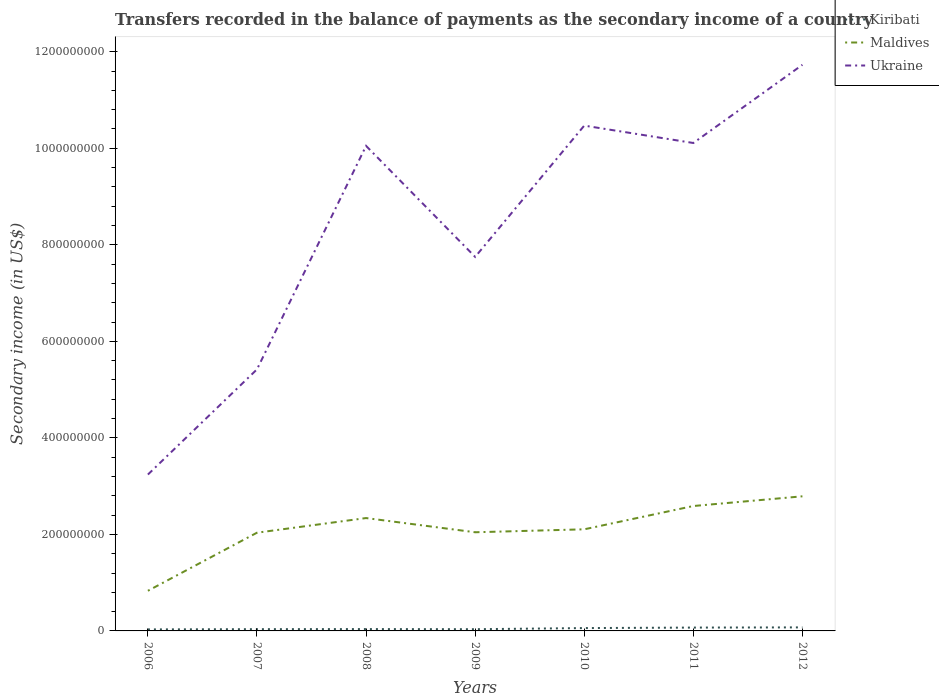Does the line corresponding to Ukraine intersect with the line corresponding to Kiribati?
Make the answer very short. No. Across all years, what is the maximum secondary income of in Kiribati?
Keep it short and to the point. 3.14e+06. In which year was the secondary income of in Ukraine maximum?
Offer a terse response. 2006. What is the total secondary income of in Kiribati in the graph?
Your answer should be compact. -3.76e+06. What is the difference between the highest and the second highest secondary income of in Ukraine?
Provide a short and direct response. 8.49e+08. Is the secondary income of in Kiribati strictly greater than the secondary income of in Maldives over the years?
Give a very brief answer. Yes. How many lines are there?
Your answer should be compact. 3. How many years are there in the graph?
Offer a terse response. 7. What is the difference between two consecutive major ticks on the Y-axis?
Offer a very short reply. 2.00e+08. Are the values on the major ticks of Y-axis written in scientific E-notation?
Give a very brief answer. No. Does the graph contain grids?
Offer a very short reply. No. Where does the legend appear in the graph?
Provide a succinct answer. Top right. How are the legend labels stacked?
Ensure brevity in your answer.  Vertical. What is the title of the graph?
Give a very brief answer. Transfers recorded in the balance of payments as the secondary income of a country. What is the label or title of the Y-axis?
Provide a short and direct response. Secondary income (in US$). What is the Secondary income (in US$) of Kiribati in 2006?
Your response must be concise. 3.14e+06. What is the Secondary income (in US$) in Maldives in 2006?
Offer a very short reply. 8.32e+07. What is the Secondary income (in US$) in Ukraine in 2006?
Offer a terse response. 3.24e+08. What is the Secondary income (in US$) in Kiribati in 2007?
Make the answer very short. 3.62e+06. What is the Secondary income (in US$) of Maldives in 2007?
Offer a terse response. 2.04e+08. What is the Secondary income (in US$) of Ukraine in 2007?
Keep it short and to the point. 5.42e+08. What is the Secondary income (in US$) in Kiribati in 2008?
Ensure brevity in your answer.  3.81e+06. What is the Secondary income (in US$) in Maldives in 2008?
Ensure brevity in your answer.  2.34e+08. What is the Secondary income (in US$) of Ukraine in 2008?
Ensure brevity in your answer.  1.00e+09. What is the Secondary income (in US$) in Kiribati in 2009?
Make the answer very short. 3.55e+06. What is the Secondary income (in US$) in Maldives in 2009?
Provide a short and direct response. 2.04e+08. What is the Secondary income (in US$) of Ukraine in 2009?
Your answer should be very brief. 7.75e+08. What is the Secondary income (in US$) of Kiribati in 2010?
Provide a short and direct response. 5.89e+06. What is the Secondary income (in US$) in Maldives in 2010?
Your response must be concise. 2.11e+08. What is the Secondary income (in US$) in Ukraine in 2010?
Your answer should be compact. 1.05e+09. What is the Secondary income (in US$) of Kiribati in 2011?
Provide a succinct answer. 6.92e+06. What is the Secondary income (in US$) of Maldives in 2011?
Provide a succinct answer. 2.59e+08. What is the Secondary income (in US$) of Ukraine in 2011?
Make the answer very short. 1.01e+09. What is the Secondary income (in US$) of Kiribati in 2012?
Provide a succinct answer. 7.31e+06. What is the Secondary income (in US$) of Maldives in 2012?
Ensure brevity in your answer.  2.79e+08. What is the Secondary income (in US$) in Ukraine in 2012?
Provide a short and direct response. 1.17e+09. Across all years, what is the maximum Secondary income (in US$) of Kiribati?
Provide a short and direct response. 7.31e+06. Across all years, what is the maximum Secondary income (in US$) in Maldives?
Offer a very short reply. 2.79e+08. Across all years, what is the maximum Secondary income (in US$) in Ukraine?
Your response must be concise. 1.17e+09. Across all years, what is the minimum Secondary income (in US$) of Kiribati?
Provide a short and direct response. 3.14e+06. Across all years, what is the minimum Secondary income (in US$) in Maldives?
Your response must be concise. 8.32e+07. Across all years, what is the minimum Secondary income (in US$) of Ukraine?
Your answer should be compact. 3.24e+08. What is the total Secondary income (in US$) in Kiribati in the graph?
Offer a very short reply. 3.42e+07. What is the total Secondary income (in US$) of Maldives in the graph?
Provide a succinct answer. 1.47e+09. What is the total Secondary income (in US$) of Ukraine in the graph?
Provide a succinct answer. 5.88e+09. What is the difference between the Secondary income (in US$) of Kiribati in 2006 and that in 2007?
Keep it short and to the point. -4.79e+05. What is the difference between the Secondary income (in US$) in Maldives in 2006 and that in 2007?
Offer a terse response. -1.20e+08. What is the difference between the Secondary income (in US$) in Ukraine in 2006 and that in 2007?
Give a very brief answer. -2.18e+08. What is the difference between the Secondary income (in US$) of Kiribati in 2006 and that in 2008?
Provide a succinct answer. -6.70e+05. What is the difference between the Secondary income (in US$) of Maldives in 2006 and that in 2008?
Ensure brevity in your answer.  -1.51e+08. What is the difference between the Secondary income (in US$) in Ukraine in 2006 and that in 2008?
Make the answer very short. -6.81e+08. What is the difference between the Secondary income (in US$) of Kiribati in 2006 and that in 2009?
Offer a very short reply. -4.10e+05. What is the difference between the Secondary income (in US$) in Maldives in 2006 and that in 2009?
Your answer should be very brief. -1.21e+08. What is the difference between the Secondary income (in US$) of Ukraine in 2006 and that in 2009?
Offer a terse response. -4.51e+08. What is the difference between the Secondary income (in US$) in Kiribati in 2006 and that in 2010?
Your response must be concise. -2.75e+06. What is the difference between the Secondary income (in US$) in Maldives in 2006 and that in 2010?
Make the answer very short. -1.27e+08. What is the difference between the Secondary income (in US$) in Ukraine in 2006 and that in 2010?
Provide a short and direct response. -7.23e+08. What is the difference between the Secondary income (in US$) in Kiribati in 2006 and that in 2011?
Provide a succinct answer. -3.78e+06. What is the difference between the Secondary income (in US$) in Maldives in 2006 and that in 2011?
Provide a succinct answer. -1.76e+08. What is the difference between the Secondary income (in US$) of Ukraine in 2006 and that in 2011?
Your response must be concise. -6.87e+08. What is the difference between the Secondary income (in US$) of Kiribati in 2006 and that in 2012?
Your answer should be compact. -4.17e+06. What is the difference between the Secondary income (in US$) of Maldives in 2006 and that in 2012?
Offer a terse response. -1.96e+08. What is the difference between the Secondary income (in US$) of Ukraine in 2006 and that in 2012?
Offer a terse response. -8.49e+08. What is the difference between the Secondary income (in US$) in Kiribati in 2007 and that in 2008?
Provide a short and direct response. -1.90e+05. What is the difference between the Secondary income (in US$) in Maldives in 2007 and that in 2008?
Provide a short and direct response. -3.03e+07. What is the difference between the Secondary income (in US$) of Ukraine in 2007 and that in 2008?
Keep it short and to the point. -4.63e+08. What is the difference between the Secondary income (in US$) of Kiribati in 2007 and that in 2009?
Provide a short and direct response. 6.99e+04. What is the difference between the Secondary income (in US$) of Maldives in 2007 and that in 2009?
Provide a short and direct response. -8.88e+05. What is the difference between the Secondary income (in US$) of Ukraine in 2007 and that in 2009?
Your answer should be very brief. -2.33e+08. What is the difference between the Secondary income (in US$) in Kiribati in 2007 and that in 2010?
Provide a succinct answer. -2.28e+06. What is the difference between the Secondary income (in US$) in Maldives in 2007 and that in 2010?
Your answer should be very brief. -7.01e+06. What is the difference between the Secondary income (in US$) in Ukraine in 2007 and that in 2010?
Provide a succinct answer. -5.05e+08. What is the difference between the Secondary income (in US$) in Kiribati in 2007 and that in 2011?
Give a very brief answer. -3.30e+06. What is the difference between the Secondary income (in US$) of Maldives in 2007 and that in 2011?
Provide a succinct answer. -5.53e+07. What is the difference between the Secondary income (in US$) in Ukraine in 2007 and that in 2011?
Provide a succinct answer. -4.69e+08. What is the difference between the Secondary income (in US$) in Kiribati in 2007 and that in 2012?
Your answer should be very brief. -3.69e+06. What is the difference between the Secondary income (in US$) in Maldives in 2007 and that in 2012?
Provide a succinct answer. -7.54e+07. What is the difference between the Secondary income (in US$) in Ukraine in 2007 and that in 2012?
Provide a succinct answer. -6.31e+08. What is the difference between the Secondary income (in US$) of Kiribati in 2008 and that in 2009?
Your response must be concise. 2.60e+05. What is the difference between the Secondary income (in US$) in Maldives in 2008 and that in 2009?
Provide a succinct answer. 2.94e+07. What is the difference between the Secondary income (in US$) in Ukraine in 2008 and that in 2009?
Provide a succinct answer. 2.30e+08. What is the difference between the Secondary income (in US$) of Kiribati in 2008 and that in 2010?
Give a very brief answer. -2.09e+06. What is the difference between the Secondary income (in US$) in Maldives in 2008 and that in 2010?
Make the answer very short. 2.33e+07. What is the difference between the Secondary income (in US$) in Ukraine in 2008 and that in 2010?
Ensure brevity in your answer.  -4.20e+07. What is the difference between the Secondary income (in US$) in Kiribati in 2008 and that in 2011?
Make the answer very short. -3.11e+06. What is the difference between the Secondary income (in US$) of Maldives in 2008 and that in 2011?
Provide a short and direct response. -2.50e+07. What is the difference between the Secondary income (in US$) of Ukraine in 2008 and that in 2011?
Ensure brevity in your answer.  -6.00e+06. What is the difference between the Secondary income (in US$) of Kiribati in 2008 and that in 2012?
Make the answer very short. -3.50e+06. What is the difference between the Secondary income (in US$) in Maldives in 2008 and that in 2012?
Your answer should be very brief. -4.51e+07. What is the difference between the Secondary income (in US$) in Ukraine in 2008 and that in 2012?
Provide a short and direct response. -1.68e+08. What is the difference between the Secondary income (in US$) in Kiribati in 2009 and that in 2010?
Give a very brief answer. -2.35e+06. What is the difference between the Secondary income (in US$) of Maldives in 2009 and that in 2010?
Make the answer very short. -6.12e+06. What is the difference between the Secondary income (in US$) in Ukraine in 2009 and that in 2010?
Your answer should be very brief. -2.72e+08. What is the difference between the Secondary income (in US$) of Kiribati in 2009 and that in 2011?
Your response must be concise. -3.37e+06. What is the difference between the Secondary income (in US$) of Maldives in 2009 and that in 2011?
Give a very brief answer. -5.44e+07. What is the difference between the Secondary income (in US$) of Ukraine in 2009 and that in 2011?
Keep it short and to the point. -2.36e+08. What is the difference between the Secondary income (in US$) of Kiribati in 2009 and that in 2012?
Ensure brevity in your answer.  -3.76e+06. What is the difference between the Secondary income (in US$) of Maldives in 2009 and that in 2012?
Give a very brief answer. -7.45e+07. What is the difference between the Secondary income (in US$) of Ukraine in 2009 and that in 2012?
Offer a terse response. -3.98e+08. What is the difference between the Secondary income (in US$) in Kiribati in 2010 and that in 2011?
Provide a short and direct response. -1.03e+06. What is the difference between the Secondary income (in US$) of Maldives in 2010 and that in 2011?
Provide a short and direct response. -4.83e+07. What is the difference between the Secondary income (in US$) in Ukraine in 2010 and that in 2011?
Make the answer very short. 3.60e+07. What is the difference between the Secondary income (in US$) of Kiribati in 2010 and that in 2012?
Offer a terse response. -1.42e+06. What is the difference between the Secondary income (in US$) in Maldives in 2010 and that in 2012?
Ensure brevity in your answer.  -6.84e+07. What is the difference between the Secondary income (in US$) of Ukraine in 2010 and that in 2012?
Provide a succinct answer. -1.26e+08. What is the difference between the Secondary income (in US$) of Kiribati in 2011 and that in 2012?
Keep it short and to the point. -3.91e+05. What is the difference between the Secondary income (in US$) of Maldives in 2011 and that in 2012?
Provide a succinct answer. -2.01e+07. What is the difference between the Secondary income (in US$) in Ukraine in 2011 and that in 2012?
Ensure brevity in your answer.  -1.62e+08. What is the difference between the Secondary income (in US$) in Kiribati in 2006 and the Secondary income (in US$) in Maldives in 2007?
Offer a terse response. -2.00e+08. What is the difference between the Secondary income (in US$) of Kiribati in 2006 and the Secondary income (in US$) of Ukraine in 2007?
Offer a terse response. -5.39e+08. What is the difference between the Secondary income (in US$) of Maldives in 2006 and the Secondary income (in US$) of Ukraine in 2007?
Ensure brevity in your answer.  -4.59e+08. What is the difference between the Secondary income (in US$) of Kiribati in 2006 and the Secondary income (in US$) of Maldives in 2008?
Provide a succinct answer. -2.31e+08. What is the difference between the Secondary income (in US$) of Kiribati in 2006 and the Secondary income (in US$) of Ukraine in 2008?
Give a very brief answer. -1.00e+09. What is the difference between the Secondary income (in US$) of Maldives in 2006 and the Secondary income (in US$) of Ukraine in 2008?
Your answer should be very brief. -9.22e+08. What is the difference between the Secondary income (in US$) of Kiribati in 2006 and the Secondary income (in US$) of Maldives in 2009?
Make the answer very short. -2.01e+08. What is the difference between the Secondary income (in US$) in Kiribati in 2006 and the Secondary income (in US$) in Ukraine in 2009?
Offer a very short reply. -7.72e+08. What is the difference between the Secondary income (in US$) of Maldives in 2006 and the Secondary income (in US$) of Ukraine in 2009?
Make the answer very short. -6.92e+08. What is the difference between the Secondary income (in US$) in Kiribati in 2006 and the Secondary income (in US$) in Maldives in 2010?
Provide a short and direct response. -2.07e+08. What is the difference between the Secondary income (in US$) in Kiribati in 2006 and the Secondary income (in US$) in Ukraine in 2010?
Make the answer very short. -1.04e+09. What is the difference between the Secondary income (in US$) in Maldives in 2006 and the Secondary income (in US$) in Ukraine in 2010?
Your answer should be very brief. -9.64e+08. What is the difference between the Secondary income (in US$) of Kiribati in 2006 and the Secondary income (in US$) of Maldives in 2011?
Provide a succinct answer. -2.56e+08. What is the difference between the Secondary income (in US$) in Kiribati in 2006 and the Secondary income (in US$) in Ukraine in 2011?
Offer a very short reply. -1.01e+09. What is the difference between the Secondary income (in US$) in Maldives in 2006 and the Secondary income (in US$) in Ukraine in 2011?
Make the answer very short. -9.28e+08. What is the difference between the Secondary income (in US$) of Kiribati in 2006 and the Secondary income (in US$) of Maldives in 2012?
Offer a very short reply. -2.76e+08. What is the difference between the Secondary income (in US$) of Kiribati in 2006 and the Secondary income (in US$) of Ukraine in 2012?
Provide a short and direct response. -1.17e+09. What is the difference between the Secondary income (in US$) in Maldives in 2006 and the Secondary income (in US$) in Ukraine in 2012?
Your answer should be very brief. -1.09e+09. What is the difference between the Secondary income (in US$) in Kiribati in 2007 and the Secondary income (in US$) in Maldives in 2008?
Your answer should be very brief. -2.30e+08. What is the difference between the Secondary income (in US$) in Kiribati in 2007 and the Secondary income (in US$) in Ukraine in 2008?
Provide a succinct answer. -1.00e+09. What is the difference between the Secondary income (in US$) in Maldives in 2007 and the Secondary income (in US$) in Ukraine in 2008?
Your answer should be compact. -8.01e+08. What is the difference between the Secondary income (in US$) in Kiribati in 2007 and the Secondary income (in US$) in Maldives in 2009?
Ensure brevity in your answer.  -2.01e+08. What is the difference between the Secondary income (in US$) of Kiribati in 2007 and the Secondary income (in US$) of Ukraine in 2009?
Offer a terse response. -7.71e+08. What is the difference between the Secondary income (in US$) of Maldives in 2007 and the Secondary income (in US$) of Ukraine in 2009?
Offer a terse response. -5.71e+08. What is the difference between the Secondary income (in US$) in Kiribati in 2007 and the Secondary income (in US$) in Maldives in 2010?
Give a very brief answer. -2.07e+08. What is the difference between the Secondary income (in US$) of Kiribati in 2007 and the Secondary income (in US$) of Ukraine in 2010?
Provide a short and direct response. -1.04e+09. What is the difference between the Secondary income (in US$) of Maldives in 2007 and the Secondary income (in US$) of Ukraine in 2010?
Ensure brevity in your answer.  -8.43e+08. What is the difference between the Secondary income (in US$) in Kiribati in 2007 and the Secondary income (in US$) in Maldives in 2011?
Your response must be concise. -2.55e+08. What is the difference between the Secondary income (in US$) of Kiribati in 2007 and the Secondary income (in US$) of Ukraine in 2011?
Provide a succinct answer. -1.01e+09. What is the difference between the Secondary income (in US$) of Maldives in 2007 and the Secondary income (in US$) of Ukraine in 2011?
Offer a terse response. -8.07e+08. What is the difference between the Secondary income (in US$) of Kiribati in 2007 and the Secondary income (in US$) of Maldives in 2012?
Make the answer very short. -2.75e+08. What is the difference between the Secondary income (in US$) in Kiribati in 2007 and the Secondary income (in US$) in Ukraine in 2012?
Offer a very short reply. -1.17e+09. What is the difference between the Secondary income (in US$) in Maldives in 2007 and the Secondary income (in US$) in Ukraine in 2012?
Your answer should be very brief. -9.69e+08. What is the difference between the Secondary income (in US$) in Kiribati in 2008 and the Secondary income (in US$) in Maldives in 2009?
Your response must be concise. -2.01e+08. What is the difference between the Secondary income (in US$) in Kiribati in 2008 and the Secondary income (in US$) in Ukraine in 2009?
Your answer should be compact. -7.71e+08. What is the difference between the Secondary income (in US$) of Maldives in 2008 and the Secondary income (in US$) of Ukraine in 2009?
Ensure brevity in your answer.  -5.41e+08. What is the difference between the Secondary income (in US$) of Kiribati in 2008 and the Secondary income (in US$) of Maldives in 2010?
Offer a terse response. -2.07e+08. What is the difference between the Secondary income (in US$) of Kiribati in 2008 and the Secondary income (in US$) of Ukraine in 2010?
Your answer should be compact. -1.04e+09. What is the difference between the Secondary income (in US$) in Maldives in 2008 and the Secondary income (in US$) in Ukraine in 2010?
Provide a succinct answer. -8.13e+08. What is the difference between the Secondary income (in US$) of Kiribati in 2008 and the Secondary income (in US$) of Maldives in 2011?
Your answer should be very brief. -2.55e+08. What is the difference between the Secondary income (in US$) of Kiribati in 2008 and the Secondary income (in US$) of Ukraine in 2011?
Provide a short and direct response. -1.01e+09. What is the difference between the Secondary income (in US$) of Maldives in 2008 and the Secondary income (in US$) of Ukraine in 2011?
Offer a terse response. -7.77e+08. What is the difference between the Secondary income (in US$) of Kiribati in 2008 and the Secondary income (in US$) of Maldives in 2012?
Provide a short and direct response. -2.75e+08. What is the difference between the Secondary income (in US$) of Kiribati in 2008 and the Secondary income (in US$) of Ukraine in 2012?
Offer a terse response. -1.17e+09. What is the difference between the Secondary income (in US$) in Maldives in 2008 and the Secondary income (in US$) in Ukraine in 2012?
Your answer should be compact. -9.39e+08. What is the difference between the Secondary income (in US$) in Kiribati in 2009 and the Secondary income (in US$) in Maldives in 2010?
Offer a terse response. -2.07e+08. What is the difference between the Secondary income (in US$) in Kiribati in 2009 and the Secondary income (in US$) in Ukraine in 2010?
Give a very brief answer. -1.04e+09. What is the difference between the Secondary income (in US$) of Maldives in 2009 and the Secondary income (in US$) of Ukraine in 2010?
Provide a short and direct response. -8.43e+08. What is the difference between the Secondary income (in US$) of Kiribati in 2009 and the Secondary income (in US$) of Maldives in 2011?
Your answer should be compact. -2.55e+08. What is the difference between the Secondary income (in US$) in Kiribati in 2009 and the Secondary income (in US$) in Ukraine in 2011?
Give a very brief answer. -1.01e+09. What is the difference between the Secondary income (in US$) of Maldives in 2009 and the Secondary income (in US$) of Ukraine in 2011?
Make the answer very short. -8.07e+08. What is the difference between the Secondary income (in US$) of Kiribati in 2009 and the Secondary income (in US$) of Maldives in 2012?
Your answer should be compact. -2.75e+08. What is the difference between the Secondary income (in US$) of Kiribati in 2009 and the Secondary income (in US$) of Ukraine in 2012?
Provide a short and direct response. -1.17e+09. What is the difference between the Secondary income (in US$) in Maldives in 2009 and the Secondary income (in US$) in Ukraine in 2012?
Provide a succinct answer. -9.69e+08. What is the difference between the Secondary income (in US$) in Kiribati in 2010 and the Secondary income (in US$) in Maldives in 2011?
Your answer should be compact. -2.53e+08. What is the difference between the Secondary income (in US$) in Kiribati in 2010 and the Secondary income (in US$) in Ukraine in 2011?
Your answer should be compact. -1.01e+09. What is the difference between the Secondary income (in US$) in Maldives in 2010 and the Secondary income (in US$) in Ukraine in 2011?
Your response must be concise. -8.00e+08. What is the difference between the Secondary income (in US$) in Kiribati in 2010 and the Secondary income (in US$) in Maldives in 2012?
Provide a succinct answer. -2.73e+08. What is the difference between the Secondary income (in US$) of Kiribati in 2010 and the Secondary income (in US$) of Ukraine in 2012?
Offer a terse response. -1.17e+09. What is the difference between the Secondary income (in US$) of Maldives in 2010 and the Secondary income (in US$) of Ukraine in 2012?
Provide a short and direct response. -9.62e+08. What is the difference between the Secondary income (in US$) of Kiribati in 2011 and the Secondary income (in US$) of Maldives in 2012?
Give a very brief answer. -2.72e+08. What is the difference between the Secondary income (in US$) of Kiribati in 2011 and the Secondary income (in US$) of Ukraine in 2012?
Make the answer very short. -1.17e+09. What is the difference between the Secondary income (in US$) of Maldives in 2011 and the Secondary income (in US$) of Ukraine in 2012?
Ensure brevity in your answer.  -9.14e+08. What is the average Secondary income (in US$) of Kiribati per year?
Ensure brevity in your answer.  4.89e+06. What is the average Secondary income (in US$) of Maldives per year?
Keep it short and to the point. 2.10e+08. What is the average Secondary income (in US$) in Ukraine per year?
Ensure brevity in your answer.  8.40e+08. In the year 2006, what is the difference between the Secondary income (in US$) of Kiribati and Secondary income (in US$) of Maldives?
Your response must be concise. -8.00e+07. In the year 2006, what is the difference between the Secondary income (in US$) in Kiribati and Secondary income (in US$) in Ukraine?
Give a very brief answer. -3.21e+08. In the year 2006, what is the difference between the Secondary income (in US$) in Maldives and Secondary income (in US$) in Ukraine?
Give a very brief answer. -2.41e+08. In the year 2007, what is the difference between the Secondary income (in US$) of Kiribati and Secondary income (in US$) of Maldives?
Your answer should be compact. -2.00e+08. In the year 2007, what is the difference between the Secondary income (in US$) of Kiribati and Secondary income (in US$) of Ukraine?
Your answer should be very brief. -5.38e+08. In the year 2007, what is the difference between the Secondary income (in US$) in Maldives and Secondary income (in US$) in Ukraine?
Provide a short and direct response. -3.38e+08. In the year 2008, what is the difference between the Secondary income (in US$) of Kiribati and Secondary income (in US$) of Maldives?
Provide a short and direct response. -2.30e+08. In the year 2008, what is the difference between the Secondary income (in US$) of Kiribati and Secondary income (in US$) of Ukraine?
Your response must be concise. -1.00e+09. In the year 2008, what is the difference between the Secondary income (in US$) of Maldives and Secondary income (in US$) of Ukraine?
Provide a short and direct response. -7.71e+08. In the year 2009, what is the difference between the Secondary income (in US$) in Kiribati and Secondary income (in US$) in Maldives?
Give a very brief answer. -2.01e+08. In the year 2009, what is the difference between the Secondary income (in US$) of Kiribati and Secondary income (in US$) of Ukraine?
Give a very brief answer. -7.71e+08. In the year 2009, what is the difference between the Secondary income (in US$) of Maldives and Secondary income (in US$) of Ukraine?
Your answer should be very brief. -5.71e+08. In the year 2010, what is the difference between the Secondary income (in US$) of Kiribati and Secondary income (in US$) of Maldives?
Offer a very short reply. -2.05e+08. In the year 2010, what is the difference between the Secondary income (in US$) of Kiribati and Secondary income (in US$) of Ukraine?
Ensure brevity in your answer.  -1.04e+09. In the year 2010, what is the difference between the Secondary income (in US$) of Maldives and Secondary income (in US$) of Ukraine?
Make the answer very short. -8.36e+08. In the year 2011, what is the difference between the Secondary income (in US$) of Kiribati and Secondary income (in US$) of Maldives?
Offer a very short reply. -2.52e+08. In the year 2011, what is the difference between the Secondary income (in US$) of Kiribati and Secondary income (in US$) of Ukraine?
Provide a succinct answer. -1.00e+09. In the year 2011, what is the difference between the Secondary income (in US$) of Maldives and Secondary income (in US$) of Ukraine?
Your answer should be very brief. -7.52e+08. In the year 2012, what is the difference between the Secondary income (in US$) of Kiribati and Secondary income (in US$) of Maldives?
Offer a very short reply. -2.72e+08. In the year 2012, what is the difference between the Secondary income (in US$) of Kiribati and Secondary income (in US$) of Ukraine?
Your answer should be very brief. -1.17e+09. In the year 2012, what is the difference between the Secondary income (in US$) in Maldives and Secondary income (in US$) in Ukraine?
Ensure brevity in your answer.  -8.94e+08. What is the ratio of the Secondary income (in US$) in Kiribati in 2006 to that in 2007?
Offer a terse response. 0.87. What is the ratio of the Secondary income (in US$) in Maldives in 2006 to that in 2007?
Make the answer very short. 0.41. What is the ratio of the Secondary income (in US$) of Ukraine in 2006 to that in 2007?
Offer a very short reply. 0.6. What is the ratio of the Secondary income (in US$) of Kiribati in 2006 to that in 2008?
Provide a succinct answer. 0.82. What is the ratio of the Secondary income (in US$) in Maldives in 2006 to that in 2008?
Offer a very short reply. 0.36. What is the ratio of the Secondary income (in US$) of Ukraine in 2006 to that in 2008?
Your response must be concise. 0.32. What is the ratio of the Secondary income (in US$) in Kiribati in 2006 to that in 2009?
Offer a very short reply. 0.88. What is the ratio of the Secondary income (in US$) in Maldives in 2006 to that in 2009?
Your answer should be very brief. 0.41. What is the ratio of the Secondary income (in US$) in Ukraine in 2006 to that in 2009?
Your response must be concise. 0.42. What is the ratio of the Secondary income (in US$) of Kiribati in 2006 to that in 2010?
Provide a succinct answer. 0.53. What is the ratio of the Secondary income (in US$) of Maldives in 2006 to that in 2010?
Keep it short and to the point. 0.39. What is the ratio of the Secondary income (in US$) of Ukraine in 2006 to that in 2010?
Keep it short and to the point. 0.31. What is the ratio of the Secondary income (in US$) in Kiribati in 2006 to that in 2011?
Give a very brief answer. 0.45. What is the ratio of the Secondary income (in US$) in Maldives in 2006 to that in 2011?
Provide a succinct answer. 0.32. What is the ratio of the Secondary income (in US$) in Ukraine in 2006 to that in 2011?
Your answer should be very brief. 0.32. What is the ratio of the Secondary income (in US$) in Kiribati in 2006 to that in 2012?
Your answer should be compact. 0.43. What is the ratio of the Secondary income (in US$) of Maldives in 2006 to that in 2012?
Your answer should be very brief. 0.3. What is the ratio of the Secondary income (in US$) in Ukraine in 2006 to that in 2012?
Offer a terse response. 0.28. What is the ratio of the Secondary income (in US$) in Kiribati in 2007 to that in 2008?
Provide a short and direct response. 0.95. What is the ratio of the Secondary income (in US$) in Maldives in 2007 to that in 2008?
Your response must be concise. 0.87. What is the ratio of the Secondary income (in US$) of Ukraine in 2007 to that in 2008?
Make the answer very short. 0.54. What is the ratio of the Secondary income (in US$) in Kiribati in 2007 to that in 2009?
Provide a succinct answer. 1.02. What is the ratio of the Secondary income (in US$) of Maldives in 2007 to that in 2009?
Provide a short and direct response. 1. What is the ratio of the Secondary income (in US$) of Ukraine in 2007 to that in 2009?
Offer a very short reply. 0.7. What is the ratio of the Secondary income (in US$) in Kiribati in 2007 to that in 2010?
Provide a succinct answer. 0.61. What is the ratio of the Secondary income (in US$) of Maldives in 2007 to that in 2010?
Offer a terse response. 0.97. What is the ratio of the Secondary income (in US$) in Ukraine in 2007 to that in 2010?
Your answer should be compact. 0.52. What is the ratio of the Secondary income (in US$) of Kiribati in 2007 to that in 2011?
Your response must be concise. 0.52. What is the ratio of the Secondary income (in US$) in Maldives in 2007 to that in 2011?
Give a very brief answer. 0.79. What is the ratio of the Secondary income (in US$) in Ukraine in 2007 to that in 2011?
Provide a succinct answer. 0.54. What is the ratio of the Secondary income (in US$) of Kiribati in 2007 to that in 2012?
Give a very brief answer. 0.49. What is the ratio of the Secondary income (in US$) in Maldives in 2007 to that in 2012?
Provide a short and direct response. 0.73. What is the ratio of the Secondary income (in US$) of Ukraine in 2007 to that in 2012?
Your answer should be compact. 0.46. What is the ratio of the Secondary income (in US$) in Kiribati in 2008 to that in 2009?
Your answer should be compact. 1.07. What is the ratio of the Secondary income (in US$) of Maldives in 2008 to that in 2009?
Your answer should be very brief. 1.14. What is the ratio of the Secondary income (in US$) of Ukraine in 2008 to that in 2009?
Make the answer very short. 1.3. What is the ratio of the Secondary income (in US$) of Kiribati in 2008 to that in 2010?
Your response must be concise. 0.65. What is the ratio of the Secondary income (in US$) of Maldives in 2008 to that in 2010?
Provide a succinct answer. 1.11. What is the ratio of the Secondary income (in US$) in Ukraine in 2008 to that in 2010?
Your answer should be compact. 0.96. What is the ratio of the Secondary income (in US$) of Kiribati in 2008 to that in 2011?
Provide a succinct answer. 0.55. What is the ratio of the Secondary income (in US$) in Maldives in 2008 to that in 2011?
Give a very brief answer. 0.9. What is the ratio of the Secondary income (in US$) in Kiribati in 2008 to that in 2012?
Your answer should be compact. 0.52. What is the ratio of the Secondary income (in US$) in Maldives in 2008 to that in 2012?
Your answer should be very brief. 0.84. What is the ratio of the Secondary income (in US$) of Ukraine in 2008 to that in 2012?
Your answer should be very brief. 0.86. What is the ratio of the Secondary income (in US$) in Kiribati in 2009 to that in 2010?
Provide a short and direct response. 0.6. What is the ratio of the Secondary income (in US$) of Maldives in 2009 to that in 2010?
Your answer should be compact. 0.97. What is the ratio of the Secondary income (in US$) in Ukraine in 2009 to that in 2010?
Your answer should be compact. 0.74. What is the ratio of the Secondary income (in US$) of Kiribati in 2009 to that in 2011?
Make the answer very short. 0.51. What is the ratio of the Secondary income (in US$) in Maldives in 2009 to that in 2011?
Offer a very short reply. 0.79. What is the ratio of the Secondary income (in US$) in Ukraine in 2009 to that in 2011?
Provide a short and direct response. 0.77. What is the ratio of the Secondary income (in US$) in Kiribati in 2009 to that in 2012?
Offer a terse response. 0.49. What is the ratio of the Secondary income (in US$) of Maldives in 2009 to that in 2012?
Make the answer very short. 0.73. What is the ratio of the Secondary income (in US$) of Ukraine in 2009 to that in 2012?
Make the answer very short. 0.66. What is the ratio of the Secondary income (in US$) of Kiribati in 2010 to that in 2011?
Keep it short and to the point. 0.85. What is the ratio of the Secondary income (in US$) of Maldives in 2010 to that in 2011?
Your answer should be compact. 0.81. What is the ratio of the Secondary income (in US$) in Ukraine in 2010 to that in 2011?
Offer a very short reply. 1.04. What is the ratio of the Secondary income (in US$) of Kiribati in 2010 to that in 2012?
Your response must be concise. 0.81. What is the ratio of the Secondary income (in US$) in Maldives in 2010 to that in 2012?
Your answer should be very brief. 0.75. What is the ratio of the Secondary income (in US$) of Ukraine in 2010 to that in 2012?
Your answer should be compact. 0.89. What is the ratio of the Secondary income (in US$) of Kiribati in 2011 to that in 2012?
Give a very brief answer. 0.95. What is the ratio of the Secondary income (in US$) of Maldives in 2011 to that in 2012?
Make the answer very short. 0.93. What is the ratio of the Secondary income (in US$) in Ukraine in 2011 to that in 2012?
Make the answer very short. 0.86. What is the difference between the highest and the second highest Secondary income (in US$) in Kiribati?
Ensure brevity in your answer.  3.91e+05. What is the difference between the highest and the second highest Secondary income (in US$) of Maldives?
Provide a succinct answer. 2.01e+07. What is the difference between the highest and the second highest Secondary income (in US$) in Ukraine?
Your answer should be compact. 1.26e+08. What is the difference between the highest and the lowest Secondary income (in US$) in Kiribati?
Ensure brevity in your answer.  4.17e+06. What is the difference between the highest and the lowest Secondary income (in US$) of Maldives?
Give a very brief answer. 1.96e+08. What is the difference between the highest and the lowest Secondary income (in US$) in Ukraine?
Offer a very short reply. 8.49e+08. 